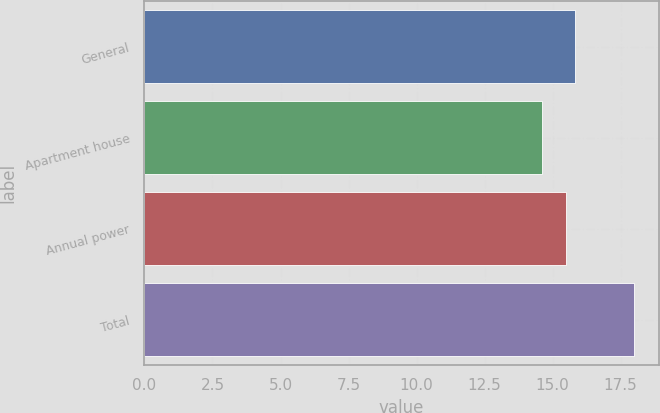Convert chart to OTSL. <chart><loc_0><loc_0><loc_500><loc_500><bar_chart><fcel>General<fcel>Apartment house<fcel>Annual power<fcel>Total<nl><fcel>15.84<fcel>14.6<fcel>15.5<fcel>18<nl></chart> 